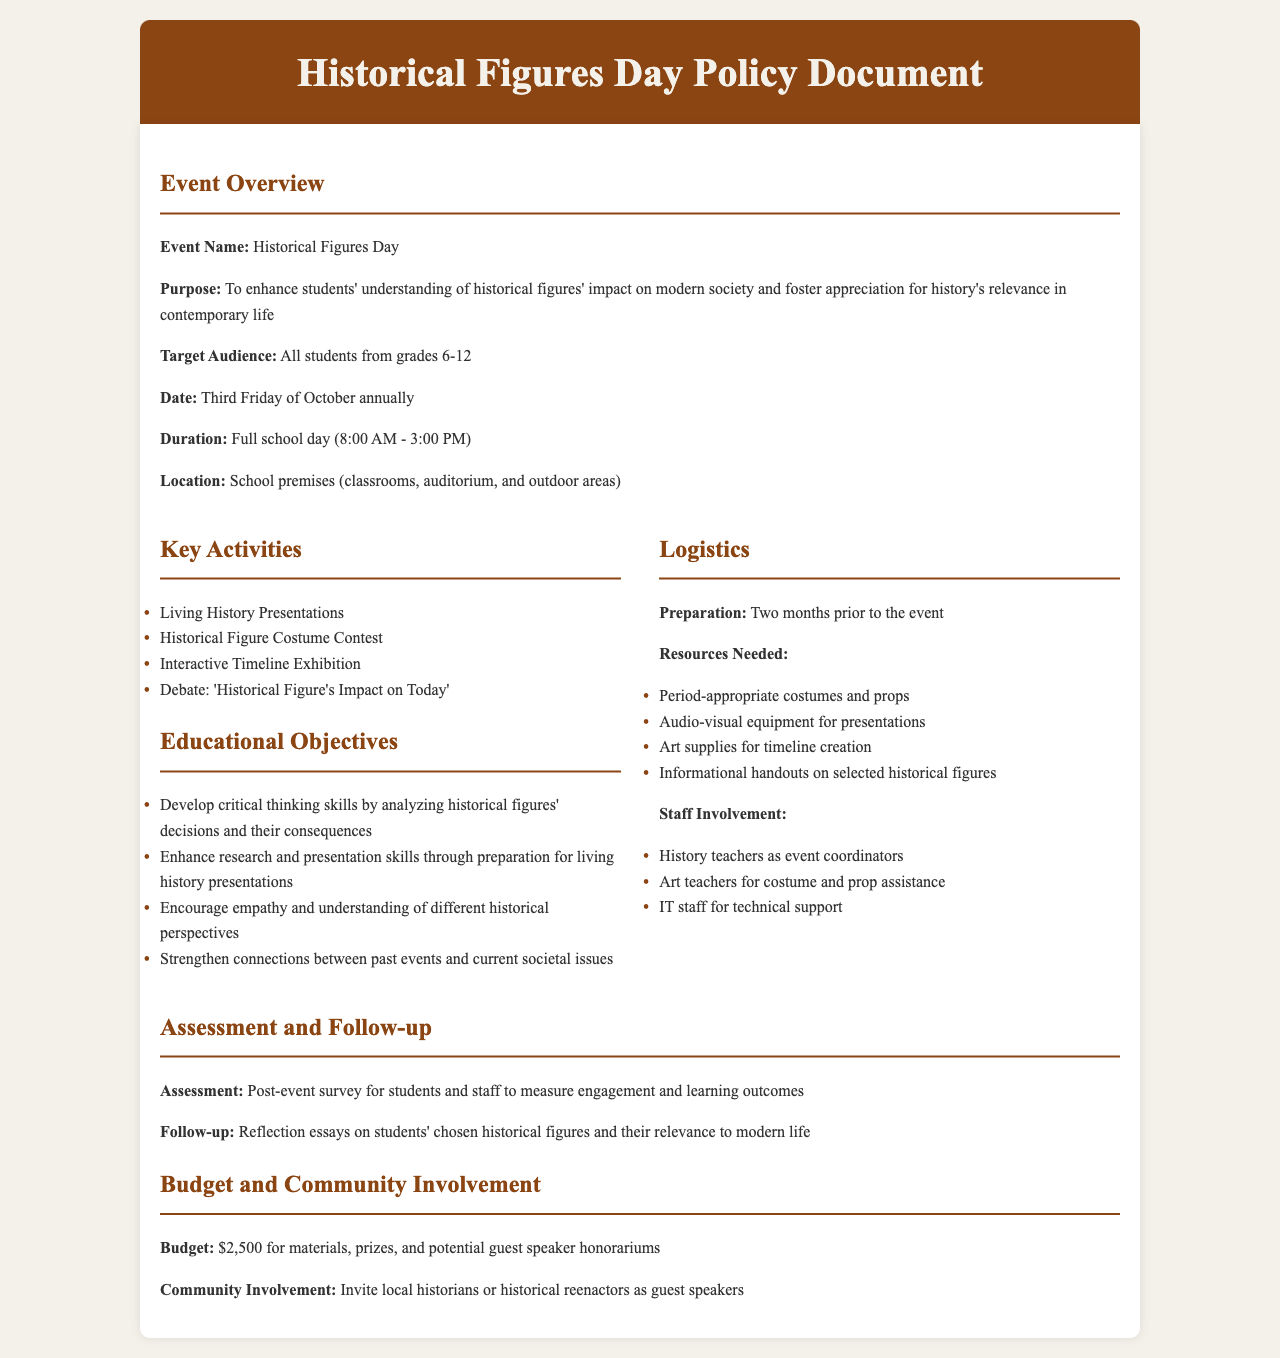what is the event name? The event name is explicitly stated at the beginning of the document under "Event Overview."
Answer: Historical Figures Day what is the target audience for the event? The target audience is specified in the "Event Overview" section of the document.
Answer: All students from grades 6-12 when will the event take place? The date of the event is mentioned in the "Event Overview" section, providing a specific schedule.
Answer: Third Friday of October annually what is the budget allocated for the event? The budget is detailed in the "Budget and Community Involvement" section of the document, specifying the financial resources.
Answer: $2,500 what are the key activities planned? The key activities are outlined in a list under the "Key Activities" section of the document.
Answer: Living History Presentations, Historical Figure Costume Contest, Interactive Timeline Exhibition, Debate: 'Historical Figure's Impact on Today' how long is the event scheduled to last? The duration of the event is stated clearly in the "Event Overview" section.
Answer: Full school day (8:00 AM - 3:00 PM) what is one educational objective of the event? Several educational objectives are listed in the document; one can be selected for the answer.
Answer: Develop critical thinking skills by analyzing historical figures' decisions and their consequences who will be involved in the event logistics? The staff involvement is specified in the "Logistics" section, detailing who will participate.
Answer: History teachers, Art teachers, IT staff what type of assessment will be implemented after the event? The assessment method is identified in the "Assessment and Follow-up" section of the document.
Answer: Post-event survey for students and staff to measure engagement and learning outcomes 